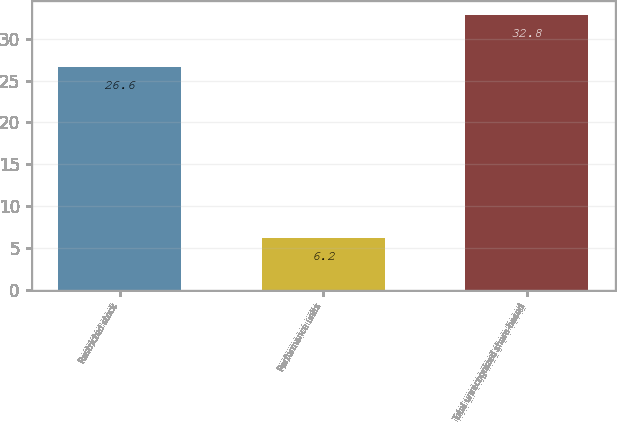Convert chart. <chart><loc_0><loc_0><loc_500><loc_500><bar_chart><fcel>Restricted stock<fcel>Performance units<fcel>Total unrecognized share-based<nl><fcel>26.6<fcel>6.2<fcel>32.8<nl></chart> 